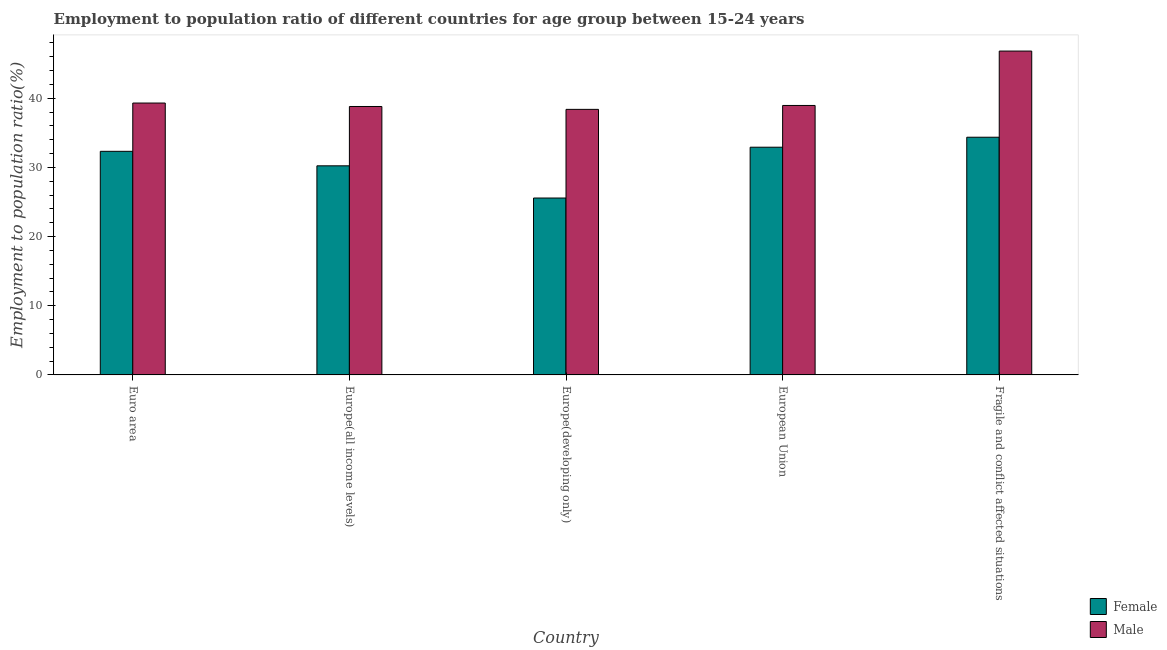Are the number of bars on each tick of the X-axis equal?
Provide a short and direct response. Yes. What is the label of the 2nd group of bars from the left?
Your answer should be compact. Europe(all income levels). In how many cases, is the number of bars for a given country not equal to the number of legend labels?
Offer a very short reply. 0. What is the employment to population ratio(female) in Euro area?
Provide a short and direct response. 32.33. Across all countries, what is the maximum employment to population ratio(male)?
Keep it short and to the point. 46.83. Across all countries, what is the minimum employment to population ratio(male)?
Offer a terse response. 38.4. In which country was the employment to population ratio(female) maximum?
Keep it short and to the point. Fragile and conflict affected situations. In which country was the employment to population ratio(female) minimum?
Provide a succinct answer. Europe(developing only). What is the total employment to population ratio(male) in the graph?
Ensure brevity in your answer.  202.33. What is the difference between the employment to population ratio(female) in Europe(all income levels) and that in Europe(developing only)?
Provide a short and direct response. 4.66. What is the difference between the employment to population ratio(female) in European Union and the employment to population ratio(male) in Europe(developing only)?
Your answer should be compact. -5.47. What is the average employment to population ratio(female) per country?
Your answer should be compact. 31.09. What is the difference between the employment to population ratio(male) and employment to population ratio(female) in Euro area?
Give a very brief answer. 6.98. What is the ratio of the employment to population ratio(male) in Euro area to that in Fragile and conflict affected situations?
Your answer should be compact. 0.84. Is the employment to population ratio(male) in Europe(developing only) less than that in Fragile and conflict affected situations?
Offer a very short reply. Yes. Is the difference between the employment to population ratio(female) in Euro area and Fragile and conflict affected situations greater than the difference between the employment to population ratio(male) in Euro area and Fragile and conflict affected situations?
Make the answer very short. Yes. What is the difference between the highest and the second highest employment to population ratio(female)?
Your response must be concise. 1.44. What is the difference between the highest and the lowest employment to population ratio(female)?
Provide a short and direct response. 8.79. Does the graph contain grids?
Provide a succinct answer. No. How are the legend labels stacked?
Offer a very short reply. Vertical. What is the title of the graph?
Offer a very short reply. Employment to population ratio of different countries for age group between 15-24 years. Does "Quality of trade" appear as one of the legend labels in the graph?
Give a very brief answer. No. What is the label or title of the X-axis?
Keep it short and to the point. Country. What is the label or title of the Y-axis?
Offer a terse response. Employment to population ratio(%). What is the Employment to population ratio(%) in Female in Euro area?
Ensure brevity in your answer.  32.33. What is the Employment to population ratio(%) in Male in Euro area?
Ensure brevity in your answer.  39.31. What is the Employment to population ratio(%) in Female in Europe(all income levels)?
Give a very brief answer. 30.24. What is the Employment to population ratio(%) in Male in Europe(all income levels)?
Offer a terse response. 38.81. What is the Employment to population ratio(%) of Female in Europe(developing only)?
Provide a succinct answer. 25.58. What is the Employment to population ratio(%) of Male in Europe(developing only)?
Your response must be concise. 38.4. What is the Employment to population ratio(%) of Female in European Union?
Offer a very short reply. 32.93. What is the Employment to population ratio(%) in Male in European Union?
Provide a short and direct response. 38.97. What is the Employment to population ratio(%) of Female in Fragile and conflict affected situations?
Provide a succinct answer. 34.37. What is the Employment to population ratio(%) in Male in Fragile and conflict affected situations?
Provide a short and direct response. 46.83. Across all countries, what is the maximum Employment to population ratio(%) of Female?
Offer a terse response. 34.37. Across all countries, what is the maximum Employment to population ratio(%) in Male?
Your answer should be very brief. 46.83. Across all countries, what is the minimum Employment to population ratio(%) in Female?
Your response must be concise. 25.58. Across all countries, what is the minimum Employment to population ratio(%) in Male?
Ensure brevity in your answer.  38.4. What is the total Employment to population ratio(%) in Female in the graph?
Provide a succinct answer. 155.45. What is the total Employment to population ratio(%) of Male in the graph?
Provide a short and direct response. 202.33. What is the difference between the Employment to population ratio(%) in Female in Euro area and that in Europe(all income levels)?
Offer a very short reply. 2.1. What is the difference between the Employment to population ratio(%) of Male in Euro area and that in Europe(all income levels)?
Provide a succinct answer. 0.5. What is the difference between the Employment to population ratio(%) in Female in Euro area and that in Europe(developing only)?
Offer a very short reply. 6.75. What is the difference between the Employment to population ratio(%) of Male in Euro area and that in Europe(developing only)?
Make the answer very short. 0.92. What is the difference between the Employment to population ratio(%) in Female in Euro area and that in European Union?
Make the answer very short. -0.59. What is the difference between the Employment to population ratio(%) of Male in Euro area and that in European Union?
Make the answer very short. 0.35. What is the difference between the Employment to population ratio(%) of Female in Euro area and that in Fragile and conflict affected situations?
Your answer should be very brief. -2.04. What is the difference between the Employment to population ratio(%) in Male in Euro area and that in Fragile and conflict affected situations?
Your answer should be very brief. -7.52. What is the difference between the Employment to population ratio(%) in Female in Europe(all income levels) and that in Europe(developing only)?
Provide a succinct answer. 4.66. What is the difference between the Employment to population ratio(%) in Male in Europe(all income levels) and that in Europe(developing only)?
Your answer should be compact. 0.42. What is the difference between the Employment to population ratio(%) of Female in Europe(all income levels) and that in European Union?
Keep it short and to the point. -2.69. What is the difference between the Employment to population ratio(%) of Male in Europe(all income levels) and that in European Union?
Make the answer very short. -0.15. What is the difference between the Employment to population ratio(%) of Female in Europe(all income levels) and that in Fragile and conflict affected situations?
Offer a very short reply. -4.13. What is the difference between the Employment to population ratio(%) of Male in Europe(all income levels) and that in Fragile and conflict affected situations?
Your answer should be compact. -8.02. What is the difference between the Employment to population ratio(%) of Female in Europe(developing only) and that in European Union?
Your answer should be very brief. -7.35. What is the difference between the Employment to population ratio(%) of Male in Europe(developing only) and that in European Union?
Offer a terse response. -0.57. What is the difference between the Employment to population ratio(%) in Female in Europe(developing only) and that in Fragile and conflict affected situations?
Provide a succinct answer. -8.79. What is the difference between the Employment to population ratio(%) of Male in Europe(developing only) and that in Fragile and conflict affected situations?
Make the answer very short. -8.43. What is the difference between the Employment to population ratio(%) of Female in European Union and that in Fragile and conflict affected situations?
Provide a short and direct response. -1.44. What is the difference between the Employment to population ratio(%) of Male in European Union and that in Fragile and conflict affected situations?
Offer a terse response. -7.87. What is the difference between the Employment to population ratio(%) of Female in Euro area and the Employment to population ratio(%) of Male in Europe(all income levels)?
Ensure brevity in your answer.  -6.48. What is the difference between the Employment to population ratio(%) of Female in Euro area and the Employment to population ratio(%) of Male in Europe(developing only)?
Provide a short and direct response. -6.07. What is the difference between the Employment to population ratio(%) of Female in Euro area and the Employment to population ratio(%) of Male in European Union?
Your response must be concise. -6.63. What is the difference between the Employment to population ratio(%) of Female in Euro area and the Employment to population ratio(%) of Male in Fragile and conflict affected situations?
Ensure brevity in your answer.  -14.5. What is the difference between the Employment to population ratio(%) in Female in Europe(all income levels) and the Employment to population ratio(%) in Male in Europe(developing only)?
Provide a short and direct response. -8.16. What is the difference between the Employment to population ratio(%) of Female in Europe(all income levels) and the Employment to population ratio(%) of Male in European Union?
Make the answer very short. -8.73. What is the difference between the Employment to population ratio(%) in Female in Europe(all income levels) and the Employment to population ratio(%) in Male in Fragile and conflict affected situations?
Your response must be concise. -16.59. What is the difference between the Employment to population ratio(%) of Female in Europe(developing only) and the Employment to population ratio(%) of Male in European Union?
Offer a terse response. -13.39. What is the difference between the Employment to population ratio(%) in Female in Europe(developing only) and the Employment to population ratio(%) in Male in Fragile and conflict affected situations?
Make the answer very short. -21.25. What is the difference between the Employment to population ratio(%) of Female in European Union and the Employment to population ratio(%) of Male in Fragile and conflict affected situations?
Make the answer very short. -13.9. What is the average Employment to population ratio(%) in Female per country?
Offer a very short reply. 31.09. What is the average Employment to population ratio(%) in Male per country?
Give a very brief answer. 40.47. What is the difference between the Employment to population ratio(%) of Female and Employment to population ratio(%) of Male in Euro area?
Provide a short and direct response. -6.98. What is the difference between the Employment to population ratio(%) of Female and Employment to population ratio(%) of Male in Europe(all income levels)?
Offer a terse response. -8.58. What is the difference between the Employment to population ratio(%) of Female and Employment to population ratio(%) of Male in Europe(developing only)?
Offer a terse response. -12.82. What is the difference between the Employment to population ratio(%) of Female and Employment to population ratio(%) of Male in European Union?
Ensure brevity in your answer.  -6.04. What is the difference between the Employment to population ratio(%) in Female and Employment to population ratio(%) in Male in Fragile and conflict affected situations?
Your answer should be very brief. -12.46. What is the ratio of the Employment to population ratio(%) in Female in Euro area to that in Europe(all income levels)?
Your answer should be compact. 1.07. What is the ratio of the Employment to population ratio(%) in Male in Euro area to that in Europe(all income levels)?
Ensure brevity in your answer.  1.01. What is the ratio of the Employment to population ratio(%) in Female in Euro area to that in Europe(developing only)?
Provide a succinct answer. 1.26. What is the ratio of the Employment to population ratio(%) in Male in Euro area to that in Europe(developing only)?
Your response must be concise. 1.02. What is the ratio of the Employment to population ratio(%) of Female in Euro area to that in Fragile and conflict affected situations?
Ensure brevity in your answer.  0.94. What is the ratio of the Employment to population ratio(%) in Male in Euro area to that in Fragile and conflict affected situations?
Keep it short and to the point. 0.84. What is the ratio of the Employment to population ratio(%) of Female in Europe(all income levels) to that in Europe(developing only)?
Provide a short and direct response. 1.18. What is the ratio of the Employment to population ratio(%) in Male in Europe(all income levels) to that in Europe(developing only)?
Offer a very short reply. 1.01. What is the ratio of the Employment to population ratio(%) of Female in Europe(all income levels) to that in European Union?
Keep it short and to the point. 0.92. What is the ratio of the Employment to population ratio(%) of Male in Europe(all income levels) to that in European Union?
Your response must be concise. 1. What is the ratio of the Employment to population ratio(%) of Female in Europe(all income levels) to that in Fragile and conflict affected situations?
Your answer should be very brief. 0.88. What is the ratio of the Employment to population ratio(%) of Male in Europe(all income levels) to that in Fragile and conflict affected situations?
Your answer should be very brief. 0.83. What is the ratio of the Employment to population ratio(%) of Female in Europe(developing only) to that in European Union?
Keep it short and to the point. 0.78. What is the ratio of the Employment to population ratio(%) of Male in Europe(developing only) to that in European Union?
Make the answer very short. 0.99. What is the ratio of the Employment to population ratio(%) in Female in Europe(developing only) to that in Fragile and conflict affected situations?
Ensure brevity in your answer.  0.74. What is the ratio of the Employment to population ratio(%) of Male in Europe(developing only) to that in Fragile and conflict affected situations?
Your response must be concise. 0.82. What is the ratio of the Employment to population ratio(%) of Female in European Union to that in Fragile and conflict affected situations?
Offer a very short reply. 0.96. What is the ratio of the Employment to population ratio(%) in Male in European Union to that in Fragile and conflict affected situations?
Provide a succinct answer. 0.83. What is the difference between the highest and the second highest Employment to population ratio(%) of Female?
Make the answer very short. 1.44. What is the difference between the highest and the second highest Employment to population ratio(%) in Male?
Your response must be concise. 7.52. What is the difference between the highest and the lowest Employment to population ratio(%) of Female?
Provide a succinct answer. 8.79. What is the difference between the highest and the lowest Employment to population ratio(%) of Male?
Your response must be concise. 8.43. 